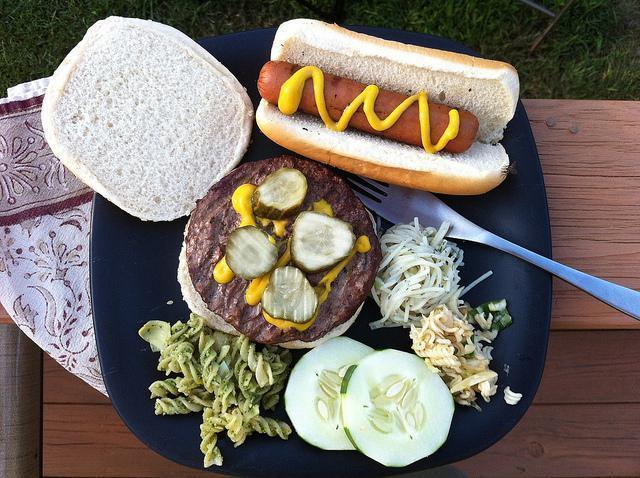How were the meats most likely cooked?
From the following four choices, select the correct answer to address the question.
Options: Bbq grill, oven, toaster, stovetop. Bbq grill. 